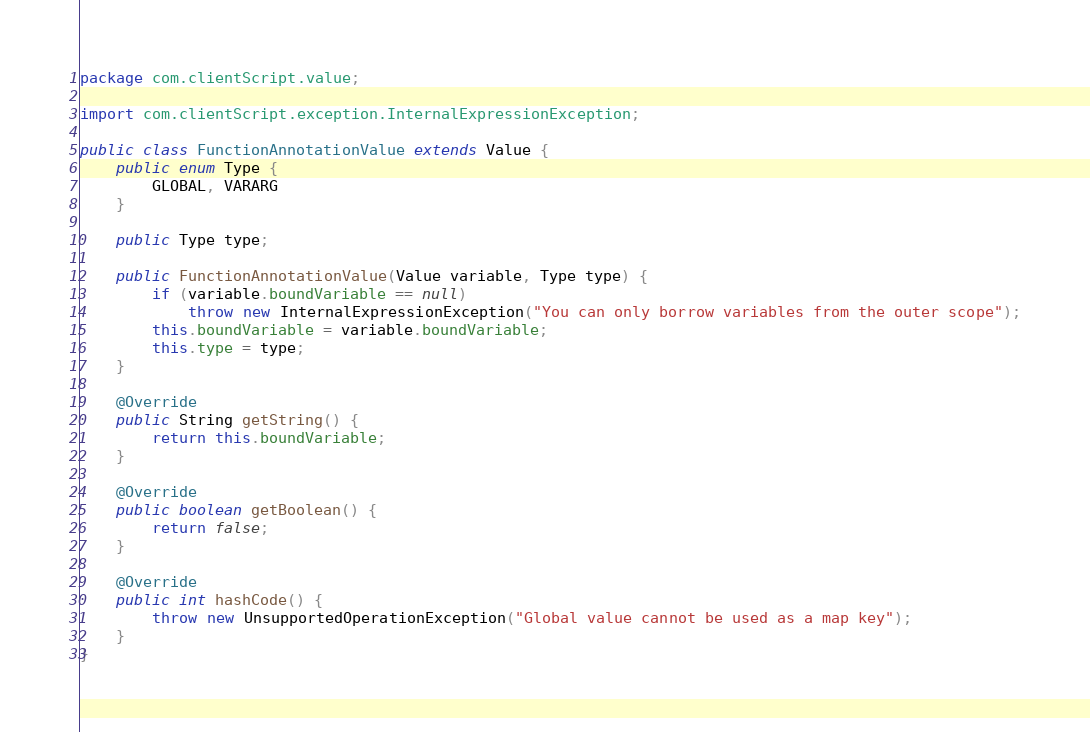Convert code to text. <code><loc_0><loc_0><loc_500><loc_500><_Java_>package com.clientScript.value;

import com.clientScript.exception.InternalExpressionException;

public class FunctionAnnotationValue extends Value {
    public enum Type {
        GLOBAL, VARARG
    }

    public Type type;
    
    public FunctionAnnotationValue(Value variable, Type type) {
        if (variable.boundVariable == null)
            throw new InternalExpressionException("You can only borrow variables from the outer scope");
        this.boundVariable = variable.boundVariable;
        this.type = type;
    }

    @Override
    public String getString() {
        return this.boundVariable;
    }

    @Override
    public boolean getBoolean() {
        return false;
    }

    @Override
    public int hashCode() {
        throw new UnsupportedOperationException("Global value cannot be used as a map key");
    }
}
</code> 